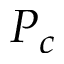Convert formula to latex. <formula><loc_0><loc_0><loc_500><loc_500>P _ { c }</formula> 